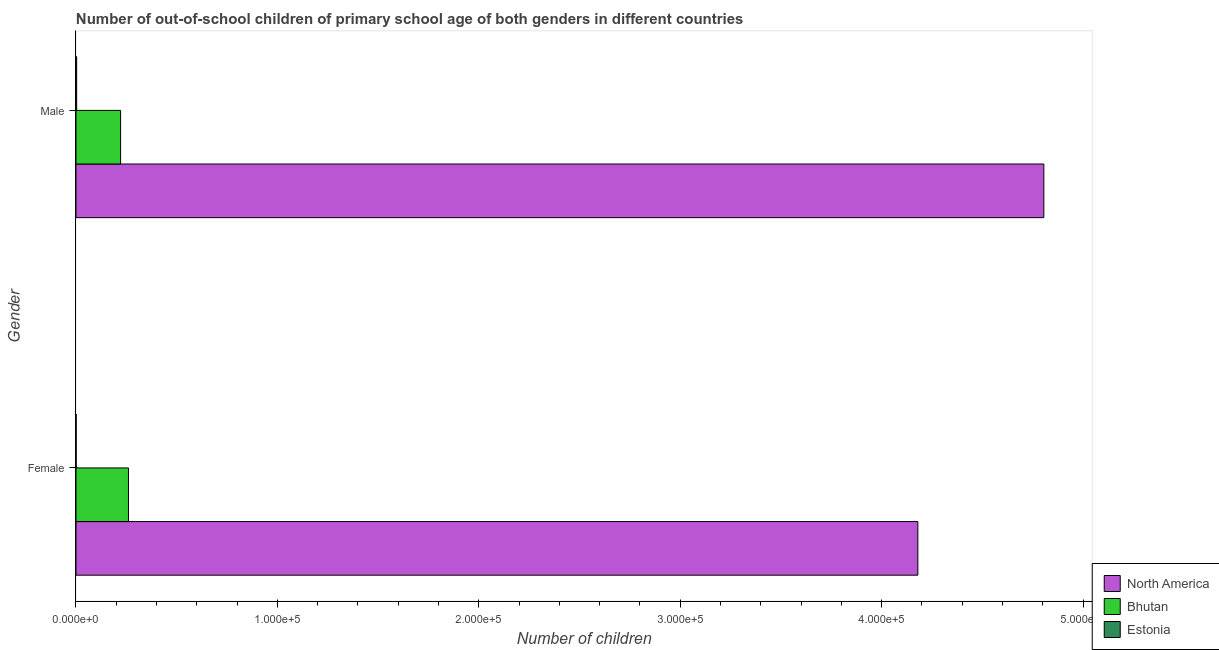How many groups of bars are there?
Give a very brief answer. 2. Are the number of bars per tick equal to the number of legend labels?
Your answer should be compact. Yes. Are the number of bars on each tick of the Y-axis equal?
Provide a succinct answer. Yes. How many bars are there on the 2nd tick from the top?
Keep it short and to the point. 3. What is the label of the 1st group of bars from the top?
Ensure brevity in your answer.  Male. What is the number of male out-of-school students in North America?
Give a very brief answer. 4.80e+05. Across all countries, what is the maximum number of male out-of-school students?
Provide a succinct answer. 4.80e+05. Across all countries, what is the minimum number of male out-of-school students?
Your answer should be compact. 334. In which country was the number of female out-of-school students maximum?
Provide a succinct answer. North America. In which country was the number of male out-of-school students minimum?
Offer a very short reply. Estonia. What is the total number of female out-of-school students in the graph?
Offer a very short reply. 4.44e+05. What is the difference between the number of female out-of-school students in North America and that in Estonia?
Your answer should be compact. 4.18e+05. What is the difference between the number of female out-of-school students in North America and the number of male out-of-school students in Bhutan?
Provide a short and direct response. 3.96e+05. What is the average number of female out-of-school students per country?
Provide a succinct answer. 1.48e+05. What is the difference between the number of female out-of-school students and number of male out-of-school students in Bhutan?
Your answer should be very brief. 3924. What is the ratio of the number of female out-of-school students in Bhutan to that in North America?
Keep it short and to the point. 0.06. What does the 1st bar from the top in Male represents?
Make the answer very short. Estonia. What does the 3rd bar from the bottom in Male represents?
Keep it short and to the point. Estonia. How many bars are there?
Ensure brevity in your answer.  6. Are all the bars in the graph horizontal?
Your response must be concise. Yes. How many countries are there in the graph?
Make the answer very short. 3. What is the difference between two consecutive major ticks on the X-axis?
Provide a short and direct response. 1.00e+05. Are the values on the major ticks of X-axis written in scientific E-notation?
Ensure brevity in your answer.  Yes. Does the graph contain any zero values?
Ensure brevity in your answer.  No. Where does the legend appear in the graph?
Ensure brevity in your answer.  Bottom right. How are the legend labels stacked?
Make the answer very short. Vertical. What is the title of the graph?
Your answer should be compact. Number of out-of-school children of primary school age of both genders in different countries. Does "Belarus" appear as one of the legend labels in the graph?
Your answer should be very brief. No. What is the label or title of the X-axis?
Your response must be concise. Number of children. What is the Number of children in North America in Female?
Your answer should be compact. 4.18e+05. What is the Number of children in Bhutan in Female?
Make the answer very short. 2.61e+04. What is the Number of children of North America in Male?
Ensure brevity in your answer.  4.80e+05. What is the Number of children of Bhutan in Male?
Make the answer very short. 2.21e+04. What is the Number of children of Estonia in Male?
Provide a short and direct response. 334. Across all Gender, what is the maximum Number of children in North America?
Provide a short and direct response. 4.80e+05. Across all Gender, what is the maximum Number of children of Bhutan?
Your answer should be compact. 2.61e+04. Across all Gender, what is the maximum Number of children of Estonia?
Your answer should be compact. 334. Across all Gender, what is the minimum Number of children in North America?
Give a very brief answer. 4.18e+05. Across all Gender, what is the minimum Number of children in Bhutan?
Provide a succinct answer. 2.21e+04. What is the total Number of children of North America in the graph?
Your response must be concise. 8.98e+05. What is the total Number of children in Bhutan in the graph?
Your response must be concise. 4.82e+04. What is the total Number of children in Estonia in the graph?
Provide a succinct answer. 419. What is the difference between the Number of children in North America in Female and that in Male?
Ensure brevity in your answer.  -6.25e+04. What is the difference between the Number of children in Bhutan in Female and that in Male?
Your answer should be compact. 3924. What is the difference between the Number of children of Estonia in Female and that in Male?
Provide a short and direct response. -249. What is the difference between the Number of children in North America in Female and the Number of children in Bhutan in Male?
Your answer should be very brief. 3.96e+05. What is the difference between the Number of children in North America in Female and the Number of children in Estonia in Male?
Provide a succinct answer. 4.18e+05. What is the difference between the Number of children of Bhutan in Female and the Number of children of Estonia in Male?
Offer a very short reply. 2.57e+04. What is the average Number of children in North America per Gender?
Your answer should be compact. 4.49e+05. What is the average Number of children of Bhutan per Gender?
Give a very brief answer. 2.41e+04. What is the average Number of children in Estonia per Gender?
Offer a very short reply. 209.5. What is the difference between the Number of children in North America and Number of children in Bhutan in Female?
Give a very brief answer. 3.92e+05. What is the difference between the Number of children of North America and Number of children of Estonia in Female?
Ensure brevity in your answer.  4.18e+05. What is the difference between the Number of children of Bhutan and Number of children of Estonia in Female?
Offer a very short reply. 2.60e+04. What is the difference between the Number of children in North America and Number of children in Bhutan in Male?
Provide a succinct answer. 4.58e+05. What is the difference between the Number of children of North America and Number of children of Estonia in Male?
Your answer should be very brief. 4.80e+05. What is the difference between the Number of children in Bhutan and Number of children in Estonia in Male?
Offer a very short reply. 2.18e+04. What is the ratio of the Number of children in North America in Female to that in Male?
Make the answer very short. 0.87. What is the ratio of the Number of children in Bhutan in Female to that in Male?
Your response must be concise. 1.18. What is the ratio of the Number of children of Estonia in Female to that in Male?
Provide a succinct answer. 0.25. What is the difference between the highest and the second highest Number of children of North America?
Provide a succinct answer. 6.25e+04. What is the difference between the highest and the second highest Number of children of Bhutan?
Your response must be concise. 3924. What is the difference between the highest and the second highest Number of children in Estonia?
Give a very brief answer. 249. What is the difference between the highest and the lowest Number of children in North America?
Give a very brief answer. 6.25e+04. What is the difference between the highest and the lowest Number of children in Bhutan?
Make the answer very short. 3924. What is the difference between the highest and the lowest Number of children of Estonia?
Your response must be concise. 249. 